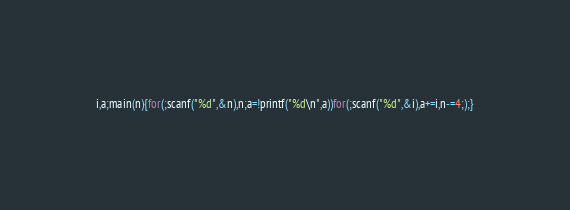<code> <loc_0><loc_0><loc_500><loc_500><_C_>i,a;main(n){for(;scanf("%d",&n),n;a=!printf("%d\n",a))for(;scanf("%d",&i),a+=i,n-=4;);}</code> 